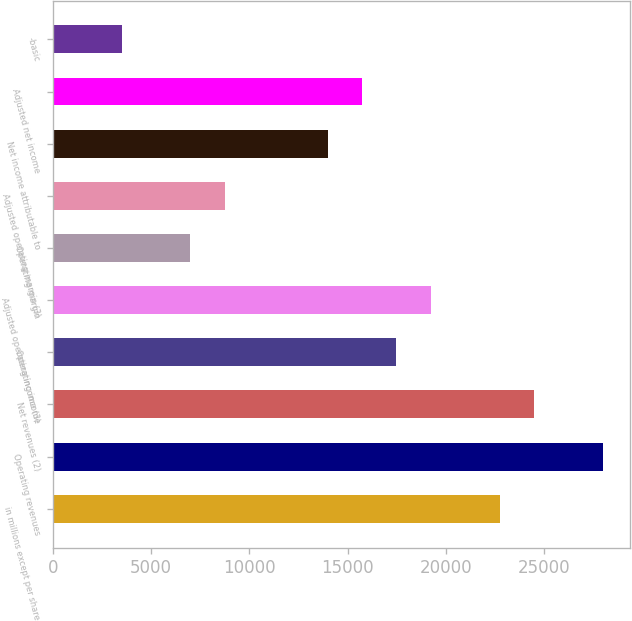<chart> <loc_0><loc_0><loc_500><loc_500><bar_chart><fcel>in millions except per share<fcel>Operating revenues<fcel>Net revenues (2)<fcel>Operating income<fcel>Adjusted operating income (3)<fcel>Operating margin<fcel>Adjusted operating margin (3)<fcel>Net income attributable to<fcel>Adjusted net income<fcel>-basic<nl><fcel>22733.2<fcel>27979.2<fcel>24481.9<fcel>17487.2<fcel>19235.9<fcel>6995.28<fcel>8743.94<fcel>13989.9<fcel>15738.6<fcel>3497.96<nl></chart> 